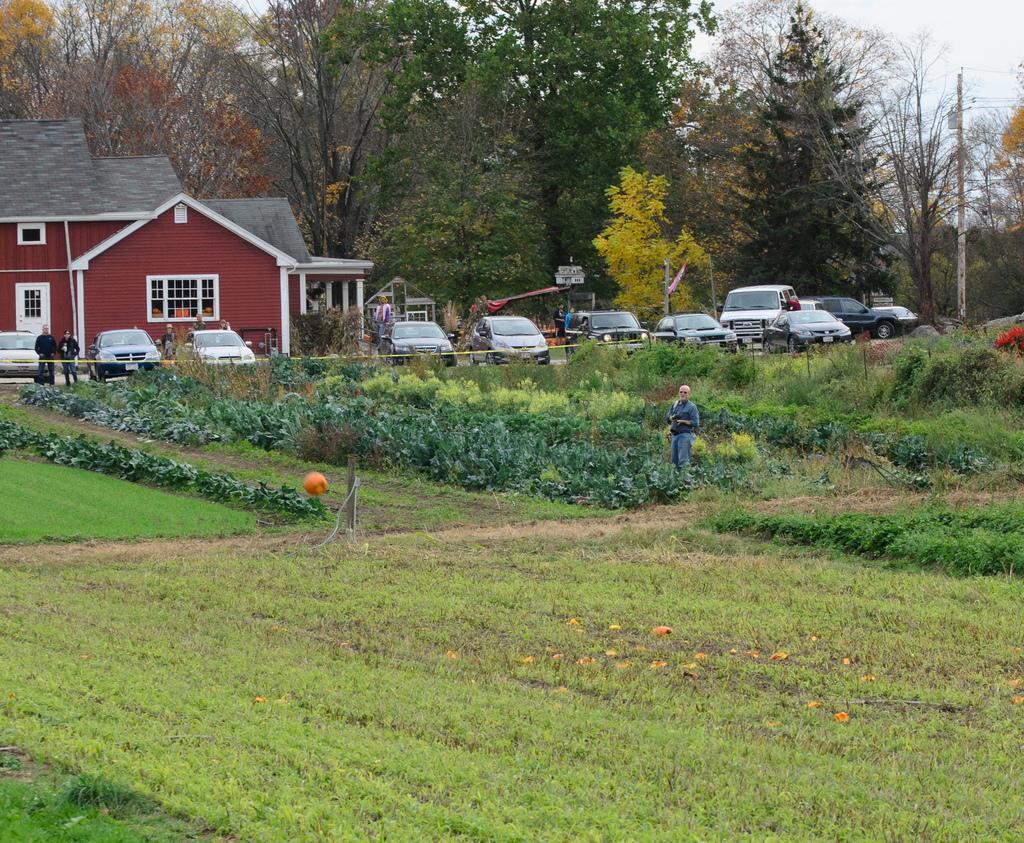Please provide a concise description of this image. In this picture we can see some grass on the ground. There are some plants and a few vehicles on the path. We can see a house on the left side. There are few trees in the background. 